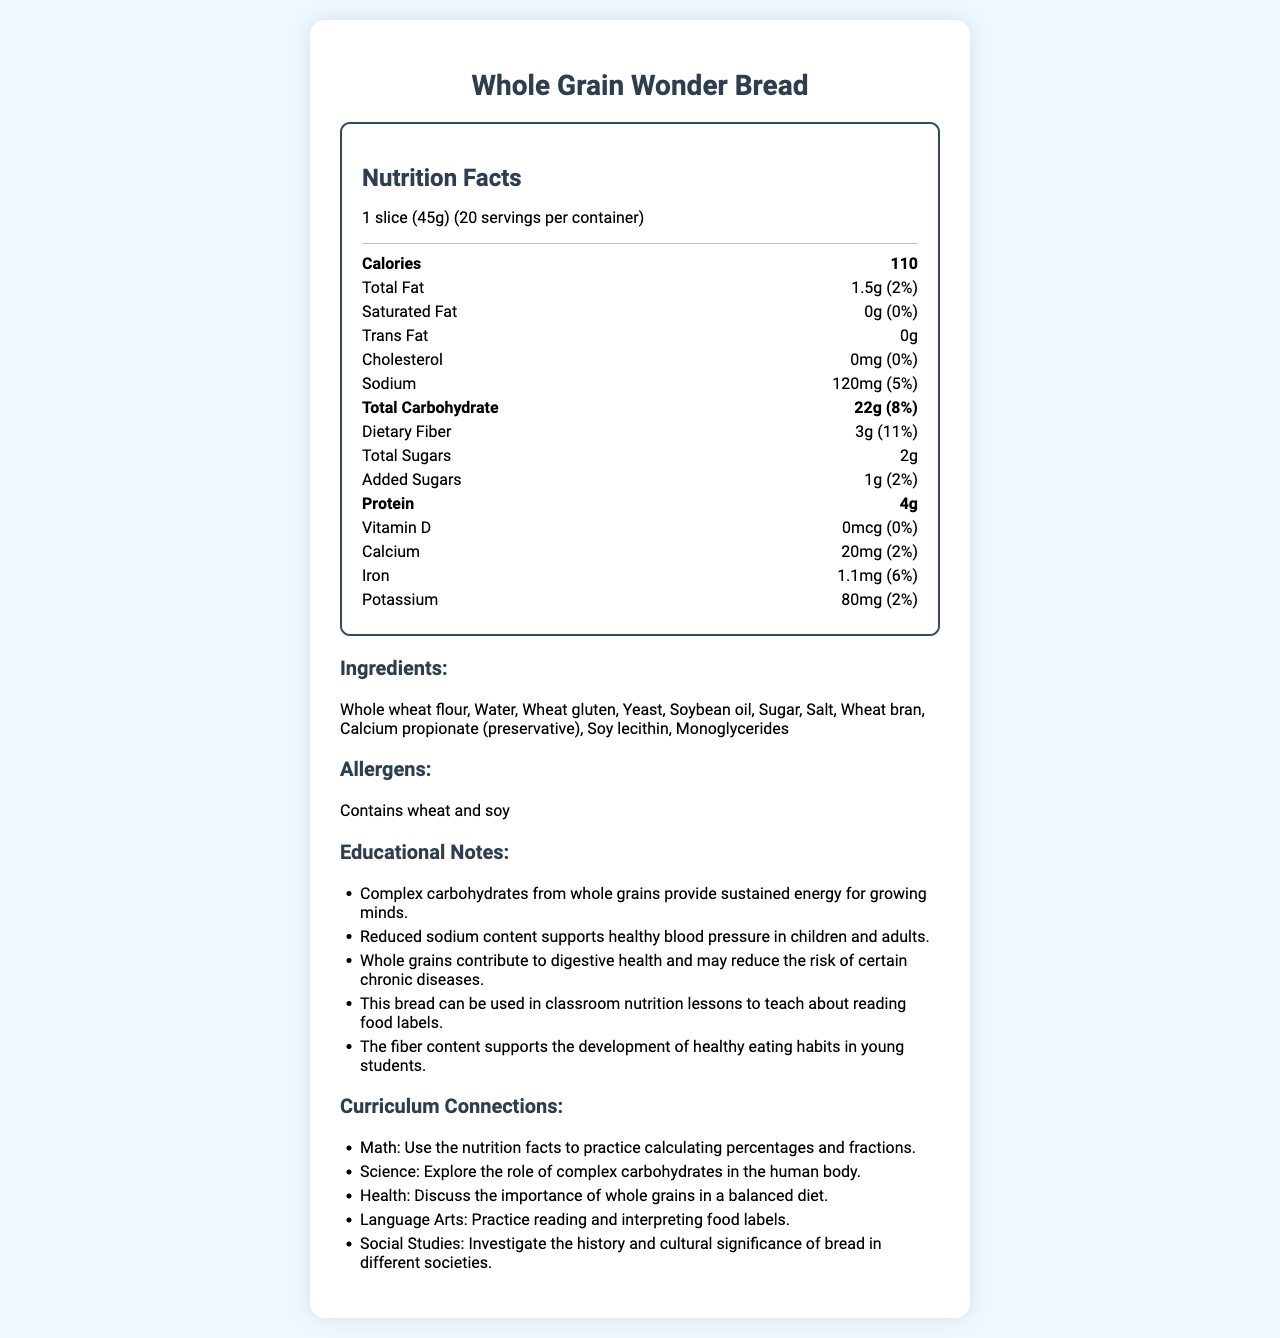what is the serving size for Whole Grain Wonder Bread? The serving size is indicated right under the product name as 1 slice (45g).
Answer: 1 slice (45g) how many servings are there per container? The document states that there are 20 servings per container.
Answer: 20 how much sodium is in one serving? Under the nutrition facts, the amount of sodium per serving is listed as 120mg.
Answer: 120mg how much dietary fiber does one serving contain? The dietary fiber content per serving is listed as 3g.
Answer: 3g what are the main ingredients in Whole Grain Wonder Bread? The ingredients are listed under the "Ingredients" section.
Answer: Whole wheat flour, Water, Wheat gluten, Yeast, Soybean oil, Sugar, Salt, Wheat bran, Calcium propionate (preservative), Soy lecithin, Monoglycerides what is the percent Daily Value of iron in one serving? Under the nutrition facts, the percent Daily Value of iron is 6%.
Answer: 6% What nutrient has the highest percent Daily Value in one serving? A. Sodium B. Dietary Fiber C. Total Carbohydrate D. Protein The percent Daily Value for dietary fiber is 11%, which is the highest compared to other nutrients listed.
Answer: B Which of the following is not an ingredient in Whole Grain Wonder Bread? Ⅰ. Whole wheat flour Ⅱ. Corn syrup Ⅲ. Yeast Ⅳ. Sugar Ⅴ. Soy lecithin Corn syrup is not listed among the ingredients, while the other options are.
Answer: Ⅱ. Corn syrup Does this product contain any trans fats? The nutrition facts indicate that the amount of trans fat is 0g.
Answer: No Summarize the entire document. The document provides detailed nutrition facts and ingredients for Whole Grain Wonder Bread. The bread contains 110 calories per serving with 22g of carbohydrates, including 3g of dietary fiber and 2g of total sugars. It has reduced sodium content at 120mg per serving and is designed to provide sustained energy through complex carbohydrates from whole grains. The bread is ideal for teaching about nutrition labels and offers various curriculum connections for subjects such as Math, Science, Health, Language Arts, and Social Studies. It also lists educational notes highlighting the benefits of complex carbohydrates and whole grains. how much vitamin D is in this product? The amount of vitamin D is listed as 0mcg in the nutrition facts.
Answer: 0mcg what is the total amount of carbohydrates per serving? The total carbohydrate content per serving is 22g as stated under nutrition facts.
Answer: 22g what percentage of daily calcium does one serving provide? The percent Daily Value for calcium is 2%.
Answer: 2% is there any cholesterol in this bread? The nutrition facts indicate that the amount of cholesterol is 0mg.
Answer: No what does the bread contain to support digestive health? The educational notes mention that whole grains and the fiber content of the bread contribute to digestive health.
Answer: Whole grains and dietary fiber How is the reduced sodium content beneficial? According to the educational notes, the reduced sodium content helps support healthy blood pressure in both children and adults.
Answer: Supports healthy blood pressure in children and adults What are some curriculum connections linked to this product? The curriculum connections section outlines different ways to integrate the nutrition facts into various subjects like Math, Science, Health, Language Arts, and Social Studies.
Answer: Math: Use the nutrition facts to practice calculating percentages and fractions. Science: Explore the role of complex carbohydrates in the human body. Health: Discuss the importance of whole grains in a balanced diet. Language Arts: Practice reading and interpreting food labels. Social Studies: Investigate the history and cultural significance of bread in different societies. Who is the manufacturer of Whole Grain Wonder Bread? The document does not provide any information about the manufacturer of the product.
Answer: Cannot be determined 